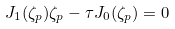<formula> <loc_0><loc_0><loc_500><loc_500>J _ { 1 } ( \zeta _ { p } ) \zeta _ { p } - \tau J _ { 0 } ( \zeta _ { p } ) = 0</formula> 